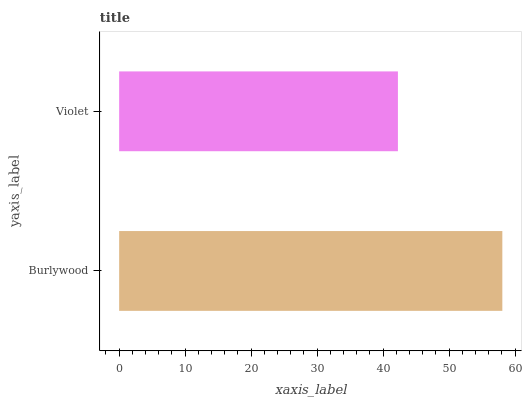Is Violet the minimum?
Answer yes or no. Yes. Is Burlywood the maximum?
Answer yes or no. Yes. Is Violet the maximum?
Answer yes or no. No. Is Burlywood greater than Violet?
Answer yes or no. Yes. Is Violet less than Burlywood?
Answer yes or no. Yes. Is Violet greater than Burlywood?
Answer yes or no. No. Is Burlywood less than Violet?
Answer yes or no. No. Is Burlywood the high median?
Answer yes or no. Yes. Is Violet the low median?
Answer yes or no. Yes. Is Violet the high median?
Answer yes or no. No. Is Burlywood the low median?
Answer yes or no. No. 